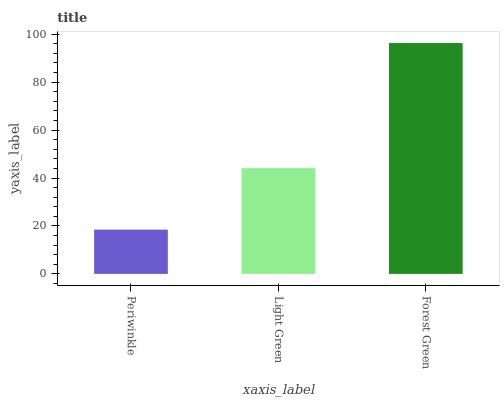Is Periwinkle the minimum?
Answer yes or no. Yes. Is Forest Green the maximum?
Answer yes or no. Yes. Is Light Green the minimum?
Answer yes or no. No. Is Light Green the maximum?
Answer yes or no. No. Is Light Green greater than Periwinkle?
Answer yes or no. Yes. Is Periwinkle less than Light Green?
Answer yes or no. Yes. Is Periwinkle greater than Light Green?
Answer yes or no. No. Is Light Green less than Periwinkle?
Answer yes or no. No. Is Light Green the high median?
Answer yes or no. Yes. Is Light Green the low median?
Answer yes or no. Yes. Is Periwinkle the high median?
Answer yes or no. No. Is Forest Green the low median?
Answer yes or no. No. 